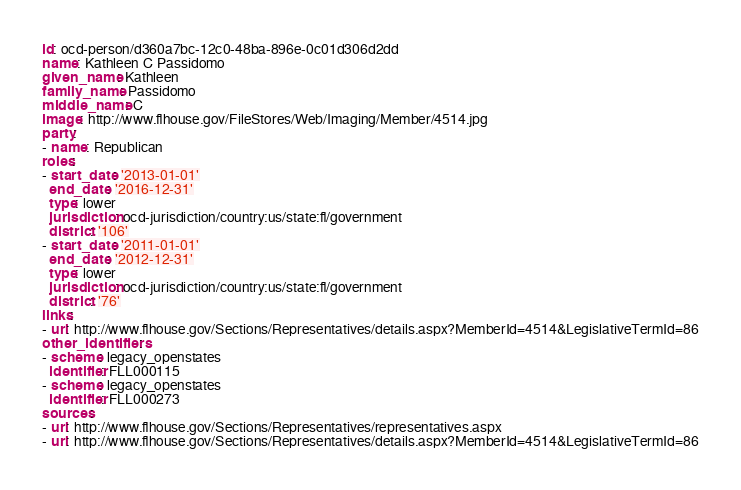Convert code to text. <code><loc_0><loc_0><loc_500><loc_500><_YAML_>id: ocd-person/d360a7bc-12c0-48ba-896e-0c01d306d2dd
name: Kathleen C Passidomo
given_name: Kathleen
family_name: Passidomo
middle_name: C
image: http://www.flhouse.gov/FileStores/Web/Imaging/Member/4514.jpg
party:
- name: Republican
roles:
- start_date: '2013-01-01'
  end_date: '2016-12-31'
  type: lower
  jurisdiction: ocd-jurisdiction/country:us/state:fl/government
  district: '106'
- start_date: '2011-01-01'
  end_date: '2012-12-31'
  type: lower
  jurisdiction: ocd-jurisdiction/country:us/state:fl/government
  district: '76'
links:
- url: http://www.flhouse.gov/Sections/Representatives/details.aspx?MemberId=4514&LegislativeTermId=86
other_identifiers:
- scheme: legacy_openstates
  identifier: FLL000115
- scheme: legacy_openstates
  identifier: FLL000273
sources:
- url: http://www.flhouse.gov/Sections/Representatives/representatives.aspx
- url: http://www.flhouse.gov/Sections/Representatives/details.aspx?MemberId=4514&LegislativeTermId=86
</code> 